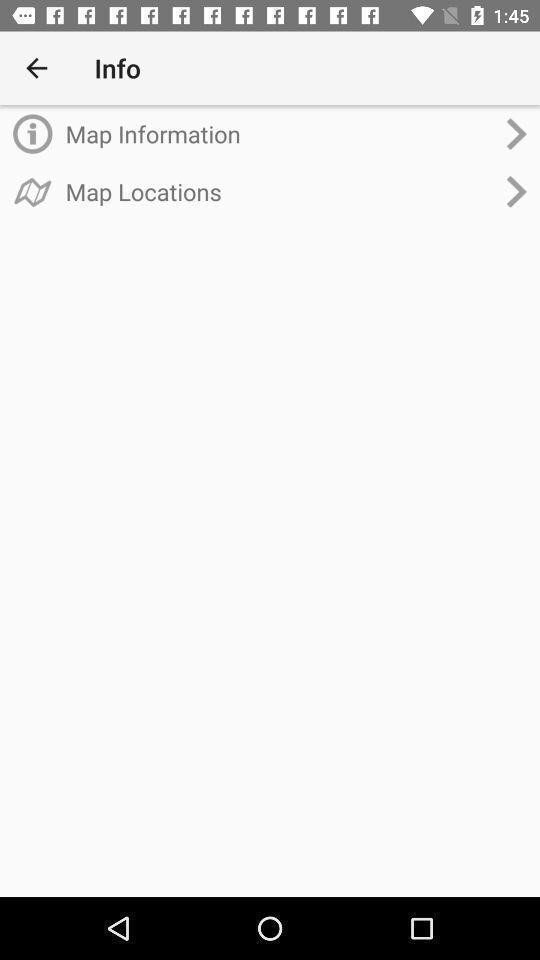Summarize the information in this screenshot. Page showing information about the map application. 